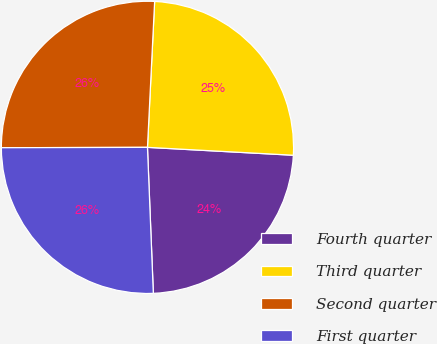<chart> <loc_0><loc_0><loc_500><loc_500><pie_chart><fcel>Fourth quarter<fcel>Third quarter<fcel>Second quarter<fcel>First quarter<nl><fcel>23.5%<fcel>25.08%<fcel>25.82%<fcel>25.6%<nl></chart> 